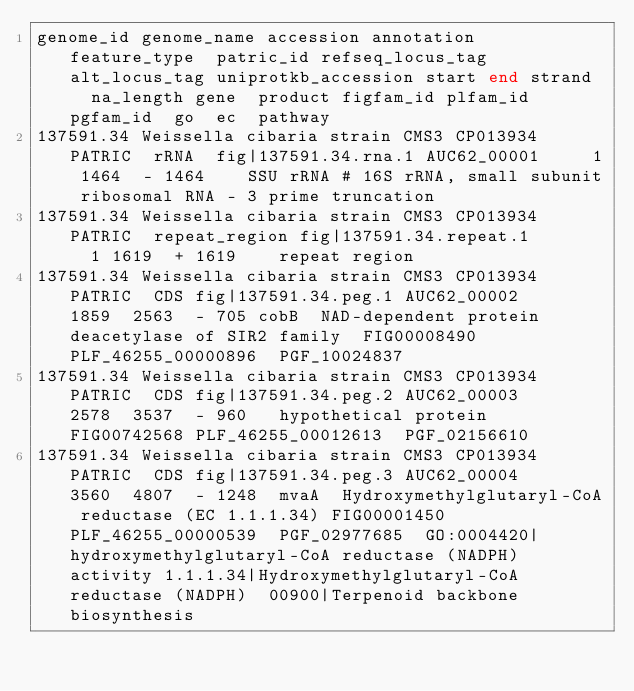Convert code to text. <code><loc_0><loc_0><loc_500><loc_500><_SQL_>genome_id	genome_name	accession	annotation	feature_type	patric_id	refseq_locus_tag	alt_locus_tag	uniprotkb_accession	start	end	strand	na_length	gene	product	figfam_id	plfam_id	pgfam_id	go	ec	pathway
137591.34	Weissella cibaria strain CMS3	CP013934	PATRIC	rRNA	fig|137591.34.rna.1	AUC62_00001			1	1464	-	1464		SSU rRNA # 16S rRNA, small subunit ribosomal RNA - 3 prime truncation						
137591.34	Weissella cibaria strain CMS3	CP013934	PATRIC	repeat_region	fig|137591.34.repeat.1				1	1619	+	1619		repeat region						
137591.34	Weissella cibaria strain CMS3	CP013934	PATRIC	CDS	fig|137591.34.peg.1	AUC62_00002			1859	2563	-	705	cobB	NAD-dependent protein deacetylase of SIR2 family	FIG00008490	PLF_46255_00000896	PGF_10024837			
137591.34	Weissella cibaria strain CMS3	CP013934	PATRIC	CDS	fig|137591.34.peg.2	AUC62_00003			2578	3537	-	960		hypothetical protein	FIG00742568	PLF_46255_00012613	PGF_02156610			
137591.34	Weissella cibaria strain CMS3	CP013934	PATRIC	CDS	fig|137591.34.peg.3	AUC62_00004			3560	4807	-	1248	mvaA	Hydroxymethylglutaryl-CoA reductase (EC 1.1.1.34)	FIG00001450	PLF_46255_00000539	PGF_02977685	GO:0004420|hydroxymethylglutaryl-CoA reductase (NADPH) activity	1.1.1.34|Hydroxymethylglutaryl-CoA reductase (NADPH)	00900|Terpenoid backbone biosynthesis</code> 